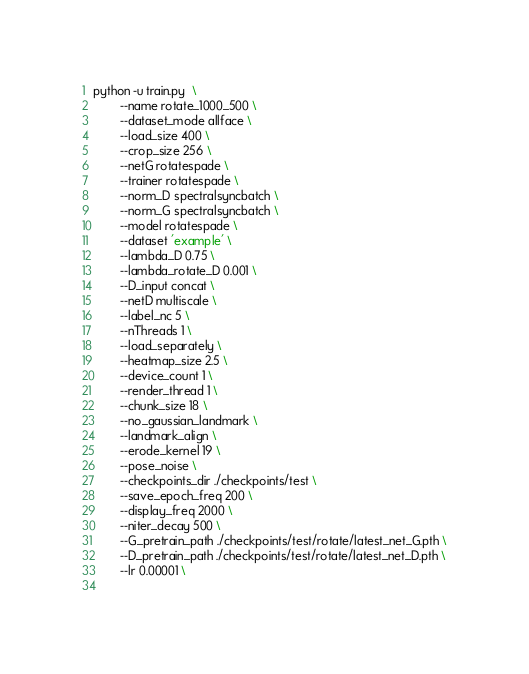<code> <loc_0><loc_0><loc_500><loc_500><_Bash_>python -u train.py  \
        --name rotate_1000_500 \
        --dataset_mode allface \
        --load_size 400 \
        --crop_size 256 \
        --netG rotatespade \
        --trainer rotatespade \
        --norm_D spectralsyncbatch \
        --norm_G spectralsyncbatch \
        --model rotatespade \
        --dataset 'example' \
        --lambda_D 0.75 \
        --lambda_rotate_D 0.001 \
        --D_input concat \
        --netD multiscale \
        --label_nc 5 \
        --nThreads 1 \
        --load_separately \
        --heatmap_size 2.5 \
        --device_count 1 \
        --render_thread 1 \
        --chunk_size 18 \
        --no_gaussian_landmark \
        --landmark_align \
        --erode_kernel 19 \
        --pose_noise \
        --checkpoints_dir ./checkpoints/test \
        --save_epoch_freq 200 \
        --display_freq 2000 \
        --niter_decay 500 \
        --G_pretrain_path ./checkpoints/test/rotate/latest_net_G.pth \
        --D_pretrain_path ./checkpoints/test/rotate/latest_net_D.pth \
        --lr 0.00001 \
        
</code> 